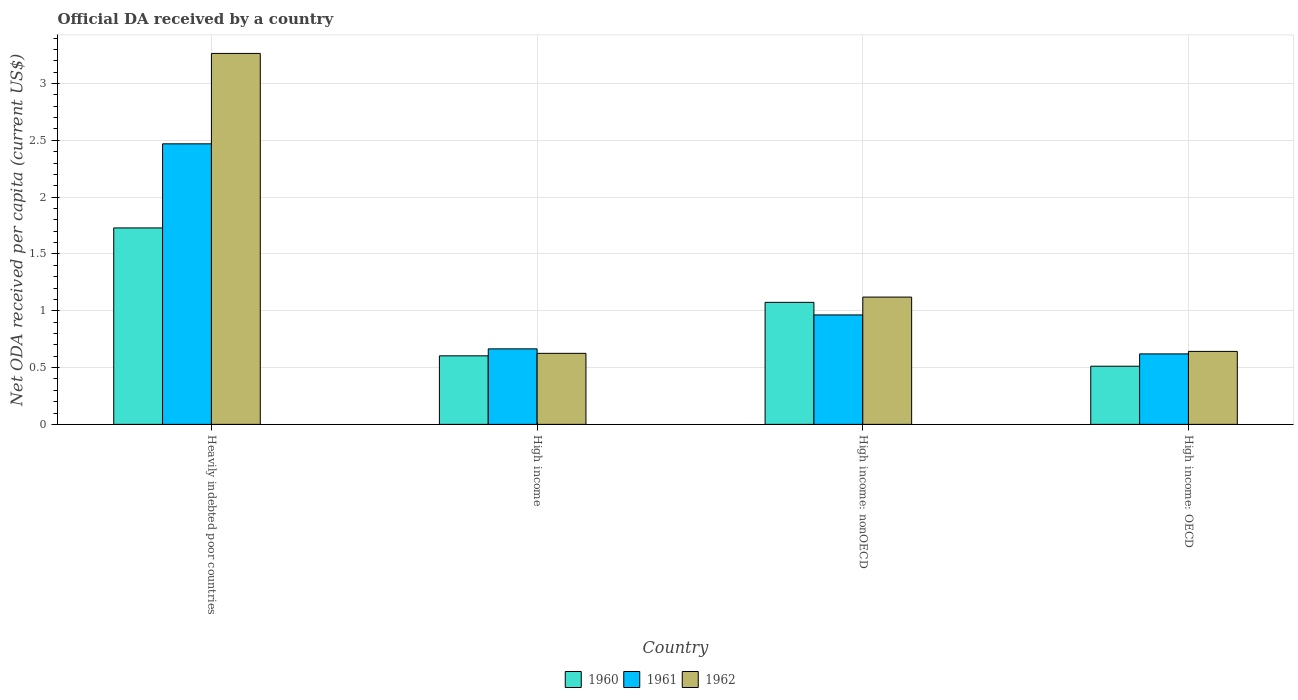How many different coloured bars are there?
Your response must be concise. 3. How many groups of bars are there?
Give a very brief answer. 4. Are the number of bars per tick equal to the number of legend labels?
Provide a short and direct response. Yes. Are the number of bars on each tick of the X-axis equal?
Your answer should be very brief. Yes. What is the label of the 3rd group of bars from the left?
Provide a short and direct response. High income: nonOECD. What is the ODA received in in 1960 in High income?
Make the answer very short. 0.6. Across all countries, what is the maximum ODA received in in 1962?
Your answer should be very brief. 3.26. Across all countries, what is the minimum ODA received in in 1960?
Keep it short and to the point. 0.51. In which country was the ODA received in in 1962 maximum?
Make the answer very short. Heavily indebted poor countries. In which country was the ODA received in in 1961 minimum?
Provide a short and direct response. High income: OECD. What is the total ODA received in in 1962 in the graph?
Provide a short and direct response. 5.65. What is the difference between the ODA received in in 1962 in High income: OECD and that in High income: nonOECD?
Keep it short and to the point. -0.48. What is the difference between the ODA received in in 1960 in High income: OECD and the ODA received in in 1961 in Heavily indebted poor countries?
Offer a very short reply. -1.96. What is the average ODA received in in 1961 per country?
Your answer should be very brief. 1.18. What is the difference between the ODA received in of/in 1961 and ODA received in of/in 1960 in High income: nonOECD?
Give a very brief answer. -0.11. In how many countries, is the ODA received in in 1961 greater than 2.5 US$?
Give a very brief answer. 0. What is the ratio of the ODA received in in 1962 in Heavily indebted poor countries to that in High income?
Your response must be concise. 5.22. Is the ODA received in in 1960 in High income less than that in High income: OECD?
Your response must be concise. No. What is the difference between the highest and the second highest ODA received in in 1961?
Your answer should be very brief. 0.3. What is the difference between the highest and the lowest ODA received in in 1961?
Keep it short and to the point. 1.85. In how many countries, is the ODA received in in 1961 greater than the average ODA received in in 1961 taken over all countries?
Keep it short and to the point. 1. Are all the bars in the graph horizontal?
Keep it short and to the point. No. How many countries are there in the graph?
Keep it short and to the point. 4. Are the values on the major ticks of Y-axis written in scientific E-notation?
Give a very brief answer. No. Does the graph contain any zero values?
Provide a succinct answer. No. Does the graph contain grids?
Give a very brief answer. Yes. How many legend labels are there?
Ensure brevity in your answer.  3. What is the title of the graph?
Ensure brevity in your answer.  Official DA received by a country. Does "1986" appear as one of the legend labels in the graph?
Your response must be concise. No. What is the label or title of the Y-axis?
Ensure brevity in your answer.  Net ODA received per capita (current US$). What is the Net ODA received per capita (current US$) of 1960 in Heavily indebted poor countries?
Your answer should be compact. 1.73. What is the Net ODA received per capita (current US$) of 1961 in Heavily indebted poor countries?
Offer a very short reply. 2.47. What is the Net ODA received per capita (current US$) in 1962 in Heavily indebted poor countries?
Provide a short and direct response. 3.26. What is the Net ODA received per capita (current US$) of 1960 in High income?
Make the answer very short. 0.6. What is the Net ODA received per capita (current US$) of 1961 in High income?
Your answer should be compact. 0.66. What is the Net ODA received per capita (current US$) in 1962 in High income?
Ensure brevity in your answer.  0.63. What is the Net ODA received per capita (current US$) in 1960 in High income: nonOECD?
Offer a terse response. 1.07. What is the Net ODA received per capita (current US$) of 1961 in High income: nonOECD?
Keep it short and to the point. 0.96. What is the Net ODA received per capita (current US$) in 1962 in High income: nonOECD?
Provide a short and direct response. 1.12. What is the Net ODA received per capita (current US$) in 1960 in High income: OECD?
Your answer should be compact. 0.51. What is the Net ODA received per capita (current US$) of 1961 in High income: OECD?
Your answer should be very brief. 0.62. What is the Net ODA received per capita (current US$) in 1962 in High income: OECD?
Provide a succinct answer. 0.64. Across all countries, what is the maximum Net ODA received per capita (current US$) in 1960?
Keep it short and to the point. 1.73. Across all countries, what is the maximum Net ODA received per capita (current US$) in 1961?
Keep it short and to the point. 2.47. Across all countries, what is the maximum Net ODA received per capita (current US$) in 1962?
Give a very brief answer. 3.26. Across all countries, what is the minimum Net ODA received per capita (current US$) in 1960?
Give a very brief answer. 0.51. Across all countries, what is the minimum Net ODA received per capita (current US$) in 1961?
Provide a succinct answer. 0.62. Across all countries, what is the minimum Net ODA received per capita (current US$) of 1962?
Make the answer very short. 0.63. What is the total Net ODA received per capita (current US$) in 1960 in the graph?
Your response must be concise. 3.92. What is the total Net ODA received per capita (current US$) of 1961 in the graph?
Provide a succinct answer. 4.72. What is the total Net ODA received per capita (current US$) of 1962 in the graph?
Give a very brief answer. 5.65. What is the difference between the Net ODA received per capita (current US$) in 1960 in Heavily indebted poor countries and that in High income?
Offer a terse response. 1.13. What is the difference between the Net ODA received per capita (current US$) of 1961 in Heavily indebted poor countries and that in High income?
Offer a very short reply. 1.8. What is the difference between the Net ODA received per capita (current US$) of 1962 in Heavily indebted poor countries and that in High income?
Keep it short and to the point. 2.64. What is the difference between the Net ODA received per capita (current US$) in 1960 in Heavily indebted poor countries and that in High income: nonOECD?
Provide a succinct answer. 0.65. What is the difference between the Net ODA received per capita (current US$) in 1961 in Heavily indebted poor countries and that in High income: nonOECD?
Keep it short and to the point. 1.51. What is the difference between the Net ODA received per capita (current US$) of 1962 in Heavily indebted poor countries and that in High income: nonOECD?
Your answer should be compact. 2.14. What is the difference between the Net ODA received per capita (current US$) of 1960 in Heavily indebted poor countries and that in High income: OECD?
Provide a short and direct response. 1.22. What is the difference between the Net ODA received per capita (current US$) of 1961 in Heavily indebted poor countries and that in High income: OECD?
Your answer should be compact. 1.85. What is the difference between the Net ODA received per capita (current US$) of 1962 in Heavily indebted poor countries and that in High income: OECD?
Your response must be concise. 2.62. What is the difference between the Net ODA received per capita (current US$) of 1960 in High income and that in High income: nonOECD?
Give a very brief answer. -0.47. What is the difference between the Net ODA received per capita (current US$) in 1961 in High income and that in High income: nonOECD?
Give a very brief answer. -0.3. What is the difference between the Net ODA received per capita (current US$) of 1962 in High income and that in High income: nonOECD?
Ensure brevity in your answer.  -0.5. What is the difference between the Net ODA received per capita (current US$) of 1960 in High income and that in High income: OECD?
Make the answer very short. 0.09. What is the difference between the Net ODA received per capita (current US$) of 1961 in High income and that in High income: OECD?
Offer a terse response. 0.04. What is the difference between the Net ODA received per capita (current US$) in 1962 in High income and that in High income: OECD?
Offer a terse response. -0.02. What is the difference between the Net ODA received per capita (current US$) of 1960 in High income: nonOECD and that in High income: OECD?
Ensure brevity in your answer.  0.56. What is the difference between the Net ODA received per capita (current US$) in 1961 in High income: nonOECD and that in High income: OECD?
Make the answer very short. 0.34. What is the difference between the Net ODA received per capita (current US$) in 1962 in High income: nonOECD and that in High income: OECD?
Offer a very short reply. 0.48. What is the difference between the Net ODA received per capita (current US$) in 1960 in Heavily indebted poor countries and the Net ODA received per capita (current US$) in 1961 in High income?
Offer a terse response. 1.06. What is the difference between the Net ODA received per capita (current US$) of 1960 in Heavily indebted poor countries and the Net ODA received per capita (current US$) of 1962 in High income?
Your answer should be very brief. 1.1. What is the difference between the Net ODA received per capita (current US$) in 1961 in Heavily indebted poor countries and the Net ODA received per capita (current US$) in 1962 in High income?
Keep it short and to the point. 1.84. What is the difference between the Net ODA received per capita (current US$) in 1960 in Heavily indebted poor countries and the Net ODA received per capita (current US$) in 1961 in High income: nonOECD?
Your answer should be very brief. 0.77. What is the difference between the Net ODA received per capita (current US$) in 1960 in Heavily indebted poor countries and the Net ODA received per capita (current US$) in 1962 in High income: nonOECD?
Your answer should be very brief. 0.61. What is the difference between the Net ODA received per capita (current US$) in 1961 in Heavily indebted poor countries and the Net ODA received per capita (current US$) in 1962 in High income: nonOECD?
Offer a very short reply. 1.35. What is the difference between the Net ODA received per capita (current US$) in 1960 in Heavily indebted poor countries and the Net ODA received per capita (current US$) in 1961 in High income: OECD?
Offer a terse response. 1.11. What is the difference between the Net ODA received per capita (current US$) of 1960 in Heavily indebted poor countries and the Net ODA received per capita (current US$) of 1962 in High income: OECD?
Provide a short and direct response. 1.09. What is the difference between the Net ODA received per capita (current US$) of 1961 in Heavily indebted poor countries and the Net ODA received per capita (current US$) of 1962 in High income: OECD?
Your answer should be compact. 1.83. What is the difference between the Net ODA received per capita (current US$) in 1960 in High income and the Net ODA received per capita (current US$) in 1961 in High income: nonOECD?
Ensure brevity in your answer.  -0.36. What is the difference between the Net ODA received per capita (current US$) of 1960 in High income and the Net ODA received per capita (current US$) of 1962 in High income: nonOECD?
Keep it short and to the point. -0.52. What is the difference between the Net ODA received per capita (current US$) of 1961 in High income and the Net ODA received per capita (current US$) of 1962 in High income: nonOECD?
Give a very brief answer. -0.46. What is the difference between the Net ODA received per capita (current US$) of 1960 in High income and the Net ODA received per capita (current US$) of 1961 in High income: OECD?
Provide a short and direct response. -0.02. What is the difference between the Net ODA received per capita (current US$) of 1960 in High income and the Net ODA received per capita (current US$) of 1962 in High income: OECD?
Provide a succinct answer. -0.04. What is the difference between the Net ODA received per capita (current US$) of 1961 in High income and the Net ODA received per capita (current US$) of 1962 in High income: OECD?
Provide a short and direct response. 0.02. What is the difference between the Net ODA received per capita (current US$) of 1960 in High income: nonOECD and the Net ODA received per capita (current US$) of 1961 in High income: OECD?
Offer a very short reply. 0.45. What is the difference between the Net ODA received per capita (current US$) of 1960 in High income: nonOECD and the Net ODA received per capita (current US$) of 1962 in High income: OECD?
Ensure brevity in your answer.  0.43. What is the difference between the Net ODA received per capita (current US$) of 1961 in High income: nonOECD and the Net ODA received per capita (current US$) of 1962 in High income: OECD?
Your answer should be compact. 0.32. What is the average Net ODA received per capita (current US$) of 1960 per country?
Your answer should be compact. 0.98. What is the average Net ODA received per capita (current US$) in 1961 per country?
Make the answer very short. 1.18. What is the average Net ODA received per capita (current US$) of 1962 per country?
Provide a succinct answer. 1.41. What is the difference between the Net ODA received per capita (current US$) of 1960 and Net ODA received per capita (current US$) of 1961 in Heavily indebted poor countries?
Your answer should be very brief. -0.74. What is the difference between the Net ODA received per capita (current US$) of 1960 and Net ODA received per capita (current US$) of 1962 in Heavily indebted poor countries?
Offer a terse response. -1.54. What is the difference between the Net ODA received per capita (current US$) in 1961 and Net ODA received per capita (current US$) in 1962 in Heavily indebted poor countries?
Your answer should be very brief. -0.8. What is the difference between the Net ODA received per capita (current US$) in 1960 and Net ODA received per capita (current US$) in 1961 in High income?
Ensure brevity in your answer.  -0.06. What is the difference between the Net ODA received per capita (current US$) of 1960 and Net ODA received per capita (current US$) of 1962 in High income?
Keep it short and to the point. -0.02. What is the difference between the Net ODA received per capita (current US$) in 1961 and Net ODA received per capita (current US$) in 1962 in High income?
Your answer should be compact. 0.04. What is the difference between the Net ODA received per capita (current US$) in 1960 and Net ODA received per capita (current US$) in 1961 in High income: nonOECD?
Give a very brief answer. 0.11. What is the difference between the Net ODA received per capita (current US$) of 1960 and Net ODA received per capita (current US$) of 1962 in High income: nonOECD?
Make the answer very short. -0.05. What is the difference between the Net ODA received per capita (current US$) of 1961 and Net ODA received per capita (current US$) of 1962 in High income: nonOECD?
Offer a very short reply. -0.16. What is the difference between the Net ODA received per capita (current US$) of 1960 and Net ODA received per capita (current US$) of 1961 in High income: OECD?
Your answer should be compact. -0.11. What is the difference between the Net ODA received per capita (current US$) in 1960 and Net ODA received per capita (current US$) in 1962 in High income: OECD?
Provide a short and direct response. -0.13. What is the difference between the Net ODA received per capita (current US$) of 1961 and Net ODA received per capita (current US$) of 1962 in High income: OECD?
Offer a terse response. -0.02. What is the ratio of the Net ODA received per capita (current US$) in 1960 in Heavily indebted poor countries to that in High income?
Give a very brief answer. 2.87. What is the ratio of the Net ODA received per capita (current US$) in 1961 in Heavily indebted poor countries to that in High income?
Keep it short and to the point. 3.72. What is the ratio of the Net ODA received per capita (current US$) of 1962 in Heavily indebted poor countries to that in High income?
Your answer should be very brief. 5.22. What is the ratio of the Net ODA received per capita (current US$) of 1960 in Heavily indebted poor countries to that in High income: nonOECD?
Offer a very short reply. 1.61. What is the ratio of the Net ODA received per capita (current US$) in 1961 in Heavily indebted poor countries to that in High income: nonOECD?
Your response must be concise. 2.56. What is the ratio of the Net ODA received per capita (current US$) in 1962 in Heavily indebted poor countries to that in High income: nonOECD?
Offer a terse response. 2.91. What is the ratio of the Net ODA received per capita (current US$) of 1960 in Heavily indebted poor countries to that in High income: OECD?
Offer a terse response. 3.38. What is the ratio of the Net ODA received per capita (current US$) of 1961 in Heavily indebted poor countries to that in High income: OECD?
Your response must be concise. 3.98. What is the ratio of the Net ODA received per capita (current US$) in 1962 in Heavily indebted poor countries to that in High income: OECD?
Ensure brevity in your answer.  5.08. What is the ratio of the Net ODA received per capita (current US$) of 1960 in High income to that in High income: nonOECD?
Offer a terse response. 0.56. What is the ratio of the Net ODA received per capita (current US$) of 1961 in High income to that in High income: nonOECD?
Offer a terse response. 0.69. What is the ratio of the Net ODA received per capita (current US$) in 1962 in High income to that in High income: nonOECD?
Your response must be concise. 0.56. What is the ratio of the Net ODA received per capita (current US$) of 1960 in High income to that in High income: OECD?
Provide a short and direct response. 1.18. What is the ratio of the Net ODA received per capita (current US$) in 1961 in High income to that in High income: OECD?
Your response must be concise. 1.07. What is the ratio of the Net ODA received per capita (current US$) of 1962 in High income to that in High income: OECD?
Your response must be concise. 0.97. What is the ratio of the Net ODA received per capita (current US$) of 1960 in High income: nonOECD to that in High income: OECD?
Your answer should be very brief. 2.1. What is the ratio of the Net ODA received per capita (current US$) of 1961 in High income: nonOECD to that in High income: OECD?
Offer a terse response. 1.55. What is the ratio of the Net ODA received per capita (current US$) of 1962 in High income: nonOECD to that in High income: OECD?
Make the answer very short. 1.74. What is the difference between the highest and the second highest Net ODA received per capita (current US$) in 1960?
Your response must be concise. 0.65. What is the difference between the highest and the second highest Net ODA received per capita (current US$) of 1961?
Give a very brief answer. 1.51. What is the difference between the highest and the second highest Net ODA received per capita (current US$) in 1962?
Keep it short and to the point. 2.14. What is the difference between the highest and the lowest Net ODA received per capita (current US$) in 1960?
Ensure brevity in your answer.  1.22. What is the difference between the highest and the lowest Net ODA received per capita (current US$) in 1961?
Provide a succinct answer. 1.85. What is the difference between the highest and the lowest Net ODA received per capita (current US$) in 1962?
Your response must be concise. 2.64. 